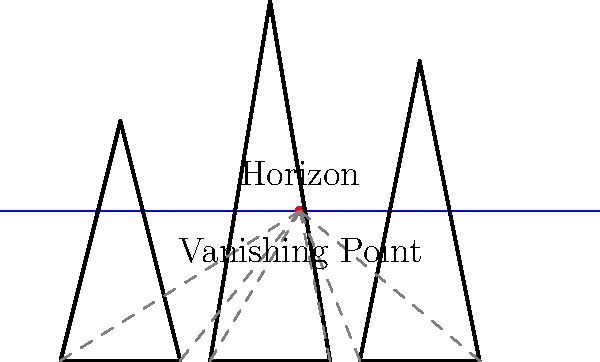In the context of painting futuristic cityscapes, which perspective drawing technique is illustrated in the diagram, and how does it contribute to creating a sense of depth and scale in a science fiction urban environment? 1. The diagram illustrates the one-point perspective technique, which is crucial for creating realistic and immersive futuristic cityscapes.

2. Key elements of one-point perspective visible in the diagram:
   a. Horizon line: The blue horizontal line represents the viewer's eye level.
   b. Vanishing point: The red dot on the horizon line where parallel lines converge.
   c. Perspective lines: Gray dashed lines converging at the vanishing point.
   d. Building outlines: Vertical lines remain parallel, while horizontal lines converge at the vanishing point.

3. Application to futuristic cityscapes:
   a. Creates a sense of depth: Objects appear smaller as they approach the vanishing point.
   b. Establishes scale: Relative sizes of buildings can be accurately represented.
   c. Enhances realism: Mimics how the human eye perceives distant objects.
   d. Allows for dramatic compositions: Placement of vanishing point can create different moods.

4. Benefits for science fiction urban environments:
   a. Exaggerates vertical elements: Ideal for towering skyscrapers and futuristic structures.
   b. Creates a sense of vastness: Perfect for depicting sprawling megacities.
   c. Allows for creative building designs: Unusual shapes can still be grounded in realistic perspective.
   d. Enhances the "futuristic" feel: Clean, converging lines evoke a sense of order and advanced urban planning.

5. Implementation in artwork:
   a. Start with horizon line and vanishing point.
   b. Use perspective lines to guide placement of buildings and structures.
   c. Vary building heights and widths for visual interest.
   d. Add details and textures while adhering to perspective guidelines.

By mastering this technique, a science fiction painter can create compelling, immersive urban landscapes that transport viewers to futuristic worlds.
Answer: One-point perspective 